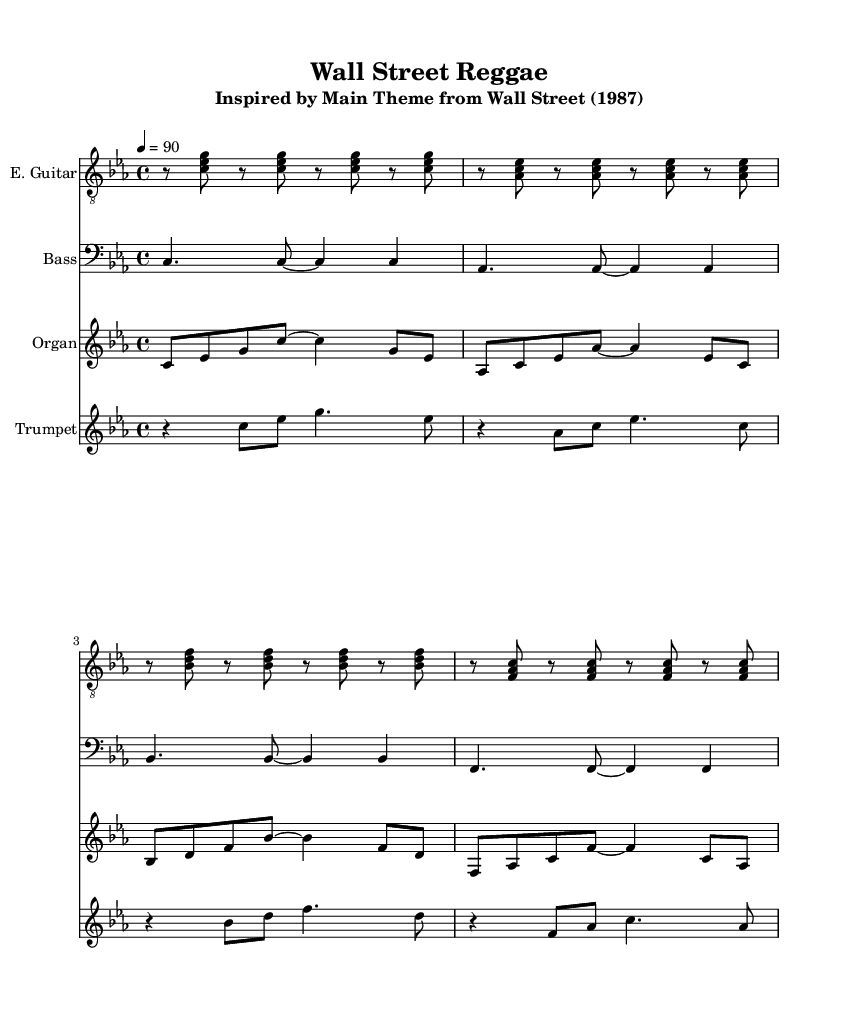What is the key signature of this music? The key signature is C minor, indicated by the three flats shown in the key signature at the beginning of the staff.
Answer: C minor What is the time signature of this music? The time signature is 4/4, which means there are four beats in a measure and the quarter note gets one beat, as denoted at the beginning of the score.
Answer: 4/4 What is the tempo marking for this piece? The tempo marking is 4 = 90, meaning the quarter note should be played at a tempo of 90 beats per minute, found at the beginning of the score under the tempo indication.
Answer: 90 How many instruments are featured in this score? The score includes four distinct instruments: electric guitar, bass, organ, and trumpet, each indicated with a separate staff.
Answer: Four Which chord appears in the first measure of the electric guitar part? The first chord in the electric guitar part is a C minor chord, consisting of the notes C, E-flat, and G, as shown in the first measure.
Answer: C minor What musical genre is this arrangement written in? This arrangement is written in the reggae genre, characterized by its offbeat rhythms and use of specific instruments, and is noted in the title and subtitle of the score.
Answer: Reggae Which instrument is playing the melody in this arrangement? The trumpet is playing the melody, which is typically the higher-pitched voice in this arrangement and leads the melodic line throughout.
Answer: Trumpet 